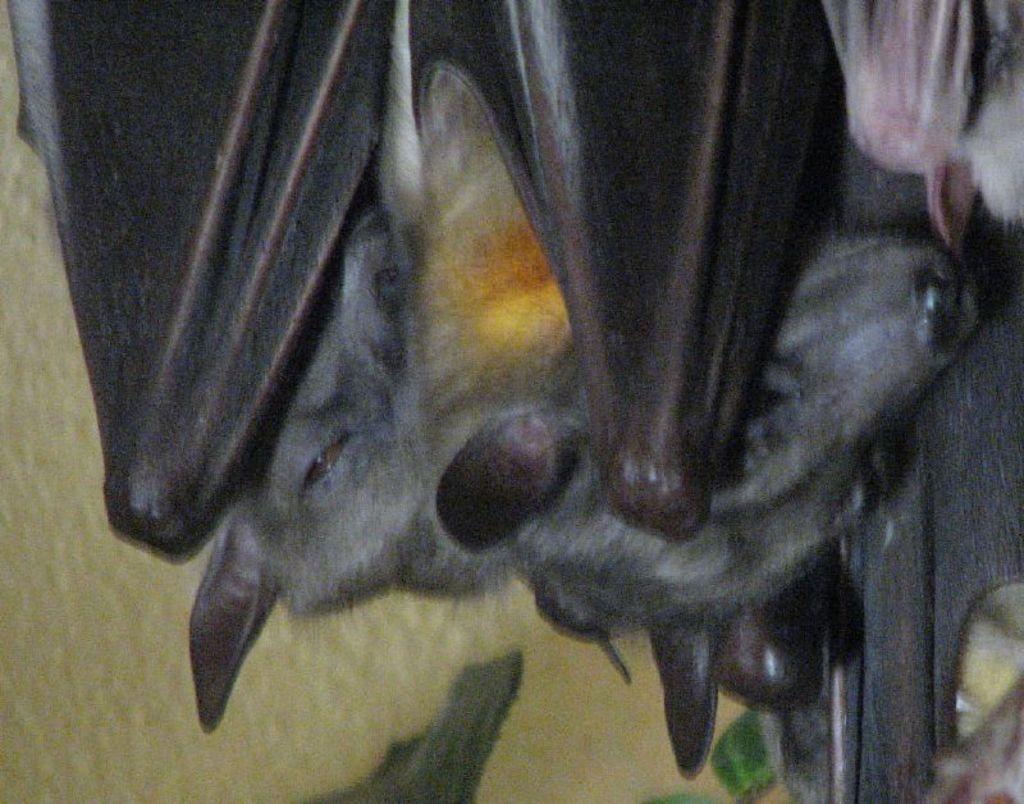How would you summarize this image in a sentence or two? In the picture we can see two bolts which are gray in color with black wings and behind it, we can see a wall which is yellow in color. 